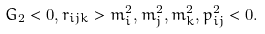<formula> <loc_0><loc_0><loc_500><loc_500>G _ { 2 } < 0 , r _ { i j k } > m _ { i } ^ { 2 } , m _ { j } ^ { 2 } , m _ { k } ^ { 2 } , p _ { i j } ^ { 2 } < 0 .</formula> 